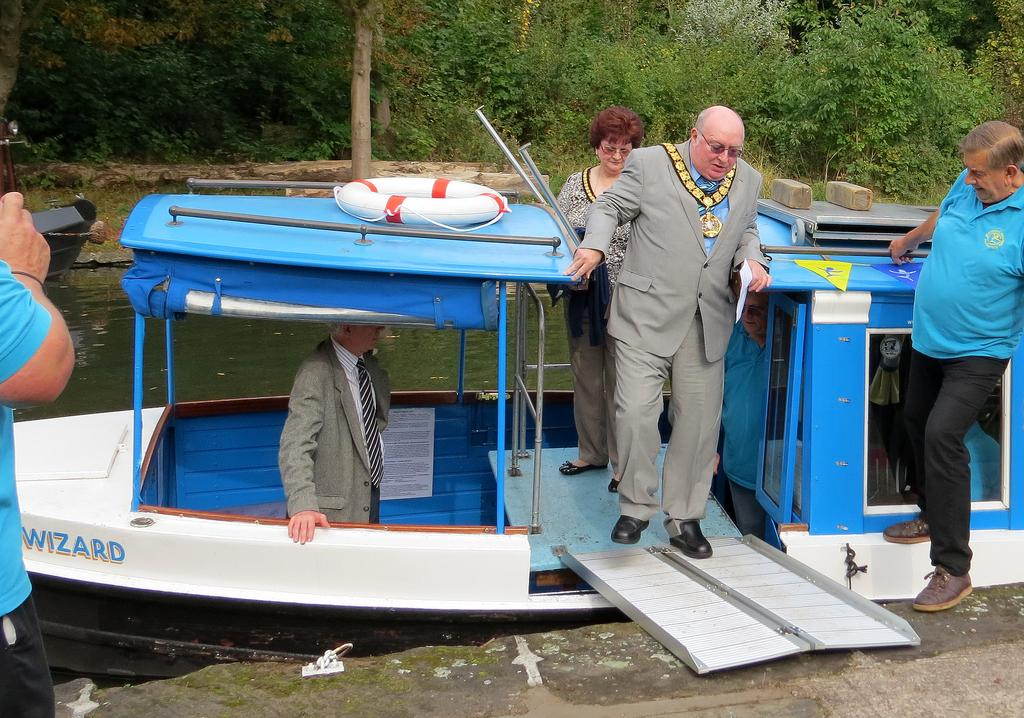What is the main subject of the image? There is a man in the image. Can you describe the man's clothing? The man is wearing a grey coat and grey trousers. Who else is present in the image? There is a woman standing in the image. What can be seen in the background of the image? The boat in the image is white and blue, and it is in the water. What type of soap is the man using to wash the boat in the image? There is no soap or boat-washing activity depicted in the image. The boat is simply in the water, and the man is not shown performing any such task. 